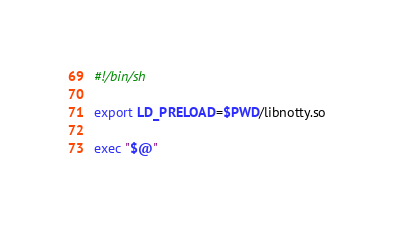Convert code to text. <code><loc_0><loc_0><loc_500><loc_500><_Bash_>#!/bin/sh

export LD_PRELOAD=$PWD/libnotty.so

exec "$@"
</code> 